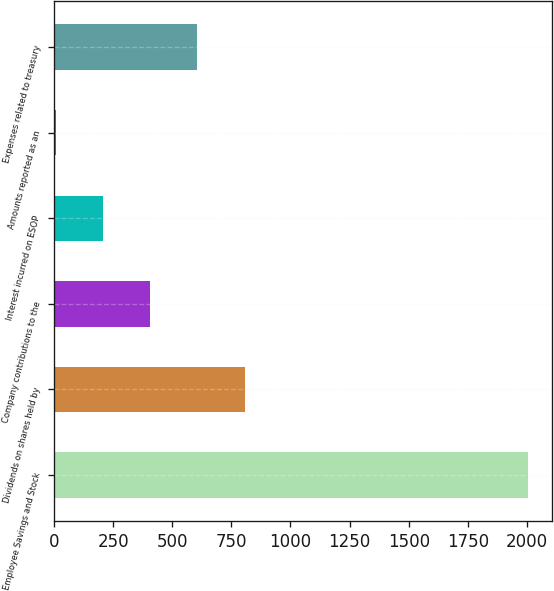<chart> <loc_0><loc_0><loc_500><loc_500><bar_chart><fcel>Employee Savings and Stock<fcel>Dividends on shares held by<fcel>Company contributions to the<fcel>Interest incurred on ESOP<fcel>Amounts reported as an<fcel>Expenses related to treasury<nl><fcel>2005<fcel>806.2<fcel>406.6<fcel>206.8<fcel>7<fcel>606.4<nl></chart> 